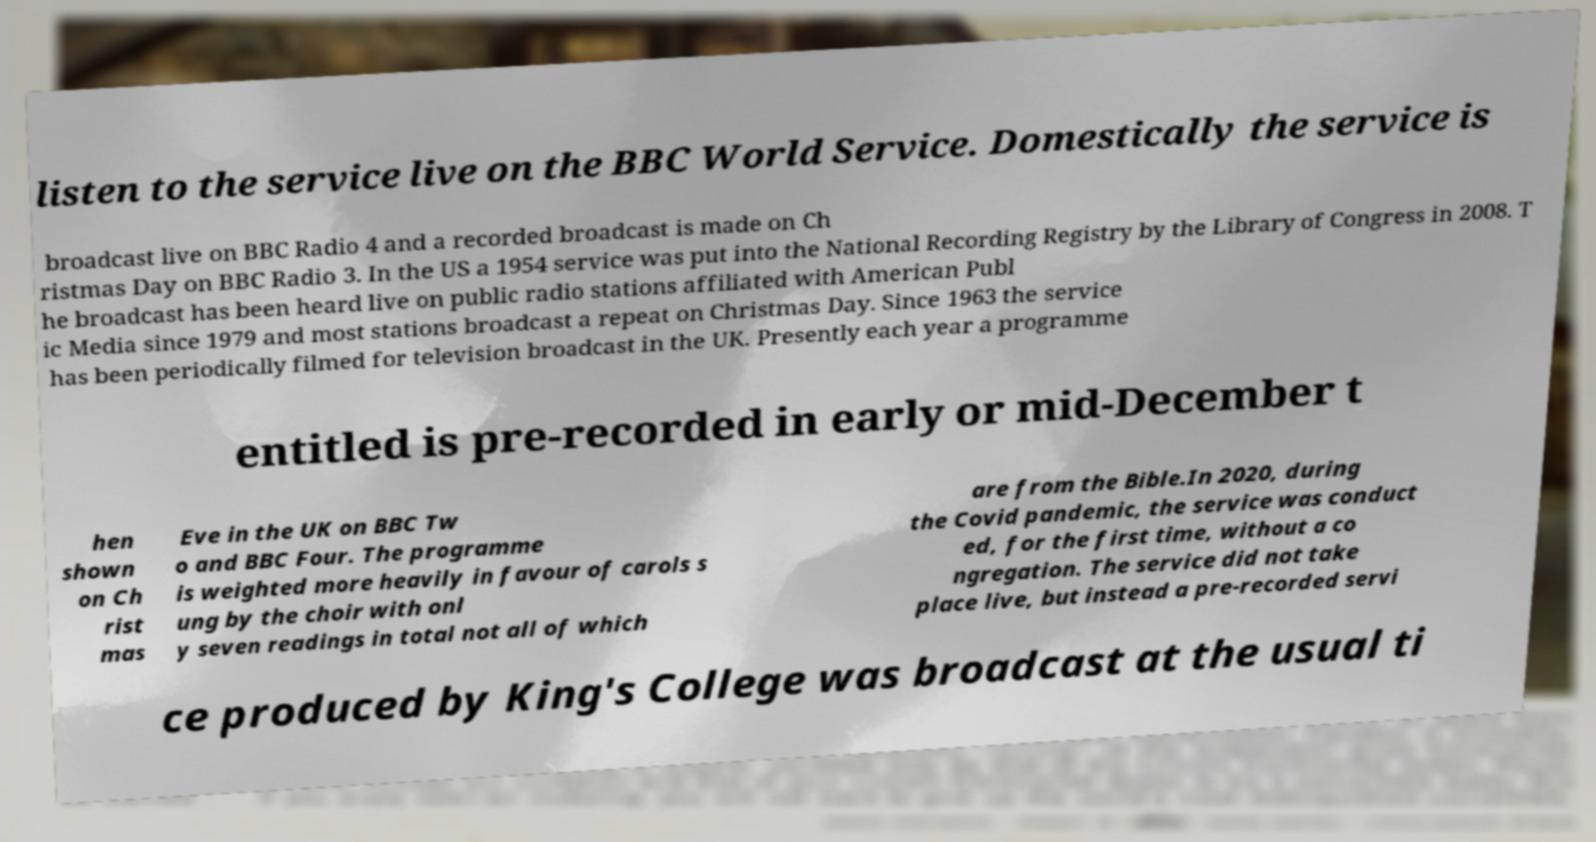Could you extract and type out the text from this image? listen to the service live on the BBC World Service. Domestically the service is broadcast live on BBC Radio 4 and a recorded broadcast is made on Ch ristmas Day on BBC Radio 3. In the US a 1954 service was put into the National Recording Registry by the Library of Congress in 2008. T he broadcast has been heard live on public radio stations affiliated with American Publ ic Media since 1979 and most stations broadcast a repeat on Christmas Day. Since 1963 the service has been periodically filmed for television broadcast in the UK. Presently each year a programme entitled is pre-recorded in early or mid-December t hen shown on Ch rist mas Eve in the UK on BBC Tw o and BBC Four. The programme is weighted more heavily in favour of carols s ung by the choir with onl y seven readings in total not all of which are from the Bible.In 2020, during the Covid pandemic, the service was conduct ed, for the first time, without a co ngregation. The service did not take place live, but instead a pre-recorded servi ce produced by King's College was broadcast at the usual ti 